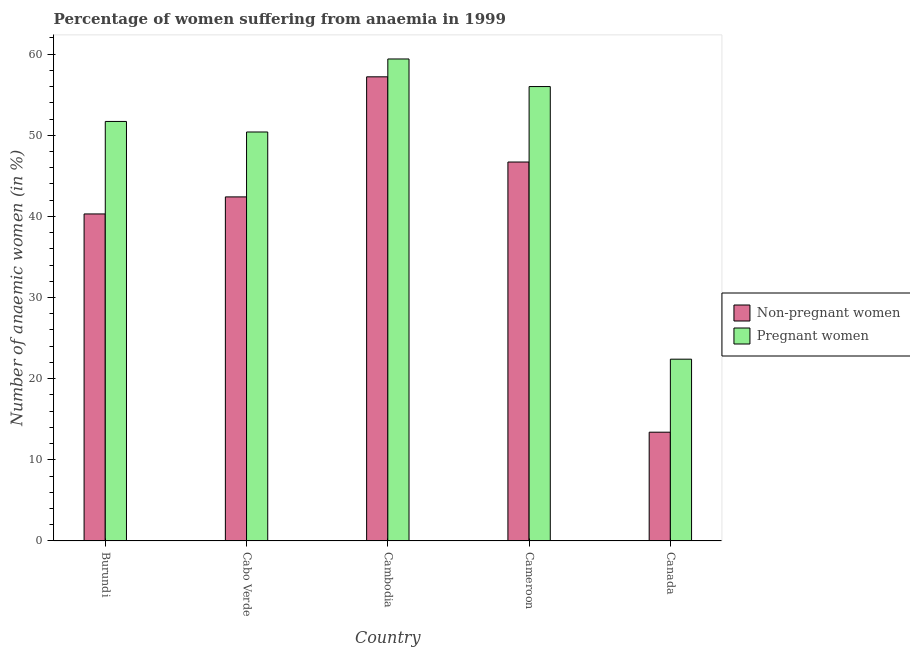Are the number of bars per tick equal to the number of legend labels?
Make the answer very short. Yes. Are the number of bars on each tick of the X-axis equal?
Offer a terse response. Yes. What is the label of the 3rd group of bars from the left?
Provide a succinct answer. Cambodia. In how many cases, is the number of bars for a given country not equal to the number of legend labels?
Make the answer very short. 0. What is the percentage of non-pregnant anaemic women in Cambodia?
Provide a short and direct response. 57.2. Across all countries, what is the maximum percentage of non-pregnant anaemic women?
Give a very brief answer. 57.2. Across all countries, what is the minimum percentage of pregnant anaemic women?
Ensure brevity in your answer.  22.4. In which country was the percentage of pregnant anaemic women maximum?
Provide a succinct answer. Cambodia. What is the total percentage of non-pregnant anaemic women in the graph?
Your answer should be compact. 200. What is the difference between the percentage of pregnant anaemic women in Burundi and that in Canada?
Your response must be concise. 29.3. What is the difference between the percentage of non-pregnant anaemic women in Canada and the percentage of pregnant anaemic women in Cabo Verde?
Your answer should be compact. -37. What is the average percentage of pregnant anaemic women per country?
Provide a succinct answer. 47.98. What is the difference between the percentage of non-pregnant anaemic women and percentage of pregnant anaemic women in Cambodia?
Keep it short and to the point. -2.2. In how many countries, is the percentage of pregnant anaemic women greater than 60 %?
Provide a succinct answer. 0. What is the ratio of the percentage of pregnant anaemic women in Burundi to that in Canada?
Your answer should be very brief. 2.31. Is the difference between the percentage of pregnant anaemic women in Burundi and Cabo Verde greater than the difference between the percentage of non-pregnant anaemic women in Burundi and Cabo Verde?
Provide a short and direct response. Yes. What is the difference between the highest and the second highest percentage of non-pregnant anaemic women?
Your answer should be very brief. 10.5. What is the difference between the highest and the lowest percentage of pregnant anaemic women?
Offer a very short reply. 37. Is the sum of the percentage of pregnant anaemic women in Burundi and Canada greater than the maximum percentage of non-pregnant anaemic women across all countries?
Your response must be concise. Yes. What does the 2nd bar from the left in Cambodia represents?
Make the answer very short. Pregnant women. What does the 2nd bar from the right in Canada represents?
Offer a very short reply. Non-pregnant women. What is the difference between two consecutive major ticks on the Y-axis?
Offer a terse response. 10. Are the values on the major ticks of Y-axis written in scientific E-notation?
Provide a short and direct response. No. Does the graph contain grids?
Offer a terse response. No. How many legend labels are there?
Your answer should be very brief. 2. How are the legend labels stacked?
Offer a very short reply. Vertical. What is the title of the graph?
Keep it short and to the point. Percentage of women suffering from anaemia in 1999. What is the label or title of the Y-axis?
Offer a very short reply. Number of anaemic women (in %). What is the Number of anaemic women (in %) in Non-pregnant women in Burundi?
Your answer should be compact. 40.3. What is the Number of anaemic women (in %) of Pregnant women in Burundi?
Provide a succinct answer. 51.7. What is the Number of anaemic women (in %) in Non-pregnant women in Cabo Verde?
Offer a terse response. 42.4. What is the Number of anaemic women (in %) in Pregnant women in Cabo Verde?
Your answer should be very brief. 50.4. What is the Number of anaemic women (in %) in Non-pregnant women in Cambodia?
Keep it short and to the point. 57.2. What is the Number of anaemic women (in %) in Pregnant women in Cambodia?
Give a very brief answer. 59.4. What is the Number of anaemic women (in %) of Non-pregnant women in Cameroon?
Your answer should be compact. 46.7. What is the Number of anaemic women (in %) in Pregnant women in Canada?
Make the answer very short. 22.4. Across all countries, what is the maximum Number of anaemic women (in %) in Non-pregnant women?
Your response must be concise. 57.2. Across all countries, what is the maximum Number of anaemic women (in %) in Pregnant women?
Your answer should be compact. 59.4. Across all countries, what is the minimum Number of anaemic women (in %) of Pregnant women?
Provide a short and direct response. 22.4. What is the total Number of anaemic women (in %) in Pregnant women in the graph?
Your response must be concise. 239.9. What is the difference between the Number of anaemic women (in %) in Non-pregnant women in Burundi and that in Cabo Verde?
Make the answer very short. -2.1. What is the difference between the Number of anaemic women (in %) of Pregnant women in Burundi and that in Cabo Verde?
Give a very brief answer. 1.3. What is the difference between the Number of anaemic women (in %) in Non-pregnant women in Burundi and that in Cambodia?
Your answer should be compact. -16.9. What is the difference between the Number of anaemic women (in %) in Non-pregnant women in Burundi and that in Cameroon?
Provide a succinct answer. -6.4. What is the difference between the Number of anaemic women (in %) of Non-pregnant women in Burundi and that in Canada?
Give a very brief answer. 26.9. What is the difference between the Number of anaemic women (in %) of Pregnant women in Burundi and that in Canada?
Keep it short and to the point. 29.3. What is the difference between the Number of anaemic women (in %) in Non-pregnant women in Cabo Verde and that in Cambodia?
Your answer should be very brief. -14.8. What is the difference between the Number of anaemic women (in %) in Non-pregnant women in Cabo Verde and that in Cameroon?
Make the answer very short. -4.3. What is the difference between the Number of anaemic women (in %) of Pregnant women in Cabo Verde and that in Cameroon?
Offer a very short reply. -5.6. What is the difference between the Number of anaemic women (in %) in Non-pregnant women in Cambodia and that in Cameroon?
Offer a terse response. 10.5. What is the difference between the Number of anaemic women (in %) in Non-pregnant women in Cambodia and that in Canada?
Give a very brief answer. 43.8. What is the difference between the Number of anaemic women (in %) of Non-pregnant women in Cameroon and that in Canada?
Offer a very short reply. 33.3. What is the difference between the Number of anaemic women (in %) of Pregnant women in Cameroon and that in Canada?
Give a very brief answer. 33.6. What is the difference between the Number of anaemic women (in %) of Non-pregnant women in Burundi and the Number of anaemic women (in %) of Pregnant women in Cambodia?
Give a very brief answer. -19.1. What is the difference between the Number of anaemic women (in %) in Non-pregnant women in Burundi and the Number of anaemic women (in %) in Pregnant women in Cameroon?
Give a very brief answer. -15.7. What is the difference between the Number of anaemic women (in %) of Non-pregnant women in Burundi and the Number of anaemic women (in %) of Pregnant women in Canada?
Offer a terse response. 17.9. What is the difference between the Number of anaemic women (in %) of Non-pregnant women in Cabo Verde and the Number of anaemic women (in %) of Pregnant women in Cambodia?
Provide a short and direct response. -17. What is the difference between the Number of anaemic women (in %) in Non-pregnant women in Cabo Verde and the Number of anaemic women (in %) in Pregnant women in Cameroon?
Provide a short and direct response. -13.6. What is the difference between the Number of anaemic women (in %) in Non-pregnant women in Cambodia and the Number of anaemic women (in %) in Pregnant women in Canada?
Your answer should be very brief. 34.8. What is the difference between the Number of anaemic women (in %) of Non-pregnant women in Cameroon and the Number of anaemic women (in %) of Pregnant women in Canada?
Your answer should be compact. 24.3. What is the average Number of anaemic women (in %) in Pregnant women per country?
Offer a terse response. 47.98. What is the difference between the Number of anaemic women (in %) of Non-pregnant women and Number of anaemic women (in %) of Pregnant women in Cameroon?
Provide a succinct answer. -9.3. What is the ratio of the Number of anaemic women (in %) of Non-pregnant women in Burundi to that in Cabo Verde?
Ensure brevity in your answer.  0.95. What is the ratio of the Number of anaemic women (in %) of Pregnant women in Burundi to that in Cabo Verde?
Provide a succinct answer. 1.03. What is the ratio of the Number of anaemic women (in %) of Non-pregnant women in Burundi to that in Cambodia?
Your answer should be compact. 0.7. What is the ratio of the Number of anaemic women (in %) in Pregnant women in Burundi to that in Cambodia?
Provide a short and direct response. 0.87. What is the ratio of the Number of anaemic women (in %) of Non-pregnant women in Burundi to that in Cameroon?
Keep it short and to the point. 0.86. What is the ratio of the Number of anaemic women (in %) of Pregnant women in Burundi to that in Cameroon?
Provide a succinct answer. 0.92. What is the ratio of the Number of anaemic women (in %) in Non-pregnant women in Burundi to that in Canada?
Provide a succinct answer. 3.01. What is the ratio of the Number of anaemic women (in %) in Pregnant women in Burundi to that in Canada?
Ensure brevity in your answer.  2.31. What is the ratio of the Number of anaemic women (in %) in Non-pregnant women in Cabo Verde to that in Cambodia?
Ensure brevity in your answer.  0.74. What is the ratio of the Number of anaemic women (in %) in Pregnant women in Cabo Verde to that in Cambodia?
Provide a short and direct response. 0.85. What is the ratio of the Number of anaemic women (in %) in Non-pregnant women in Cabo Verde to that in Cameroon?
Your answer should be compact. 0.91. What is the ratio of the Number of anaemic women (in %) of Pregnant women in Cabo Verde to that in Cameroon?
Offer a very short reply. 0.9. What is the ratio of the Number of anaemic women (in %) in Non-pregnant women in Cabo Verde to that in Canada?
Your response must be concise. 3.16. What is the ratio of the Number of anaemic women (in %) in Pregnant women in Cabo Verde to that in Canada?
Provide a succinct answer. 2.25. What is the ratio of the Number of anaemic women (in %) in Non-pregnant women in Cambodia to that in Cameroon?
Provide a short and direct response. 1.22. What is the ratio of the Number of anaemic women (in %) in Pregnant women in Cambodia to that in Cameroon?
Your response must be concise. 1.06. What is the ratio of the Number of anaemic women (in %) in Non-pregnant women in Cambodia to that in Canada?
Offer a very short reply. 4.27. What is the ratio of the Number of anaemic women (in %) in Pregnant women in Cambodia to that in Canada?
Provide a succinct answer. 2.65. What is the ratio of the Number of anaemic women (in %) of Non-pregnant women in Cameroon to that in Canada?
Offer a terse response. 3.49. What is the ratio of the Number of anaemic women (in %) of Pregnant women in Cameroon to that in Canada?
Keep it short and to the point. 2.5. What is the difference between the highest and the second highest Number of anaemic women (in %) of Pregnant women?
Your answer should be compact. 3.4. What is the difference between the highest and the lowest Number of anaemic women (in %) of Non-pregnant women?
Give a very brief answer. 43.8. What is the difference between the highest and the lowest Number of anaemic women (in %) of Pregnant women?
Your answer should be very brief. 37. 